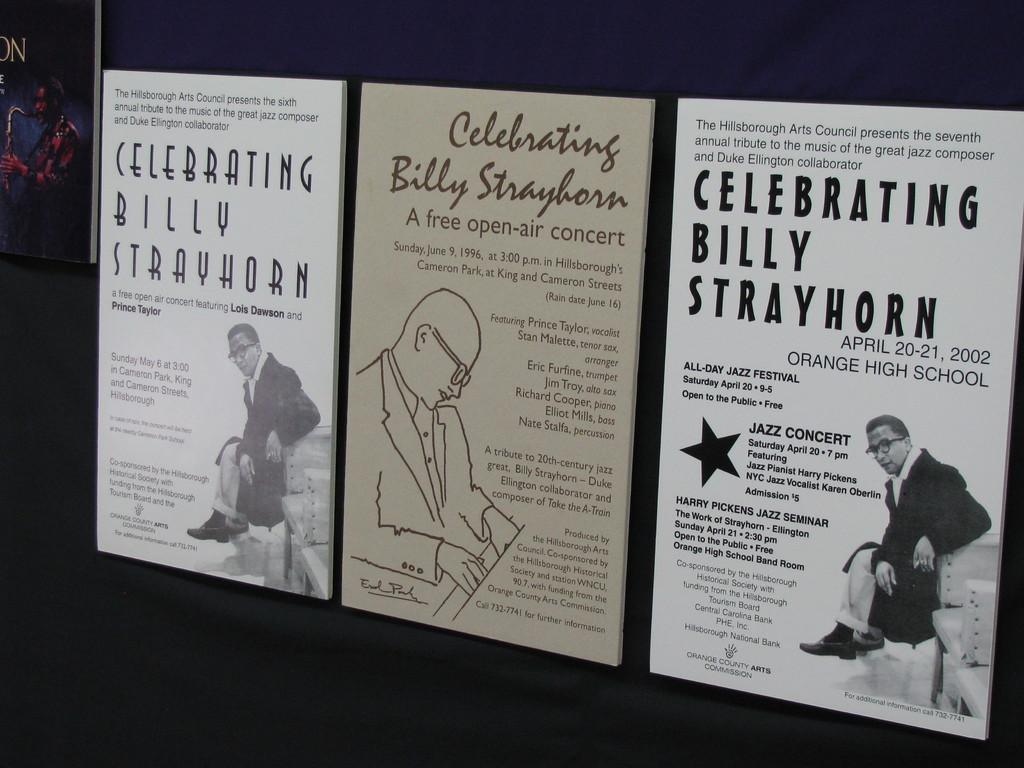<image>
Offer a succinct explanation of the picture presented. three posters for celebrating billy strayhorn on different days, may 6, june 9, and april 20-21 